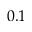Convert formula to latex. <formula><loc_0><loc_0><loc_500><loc_500>0 . 1</formula> 